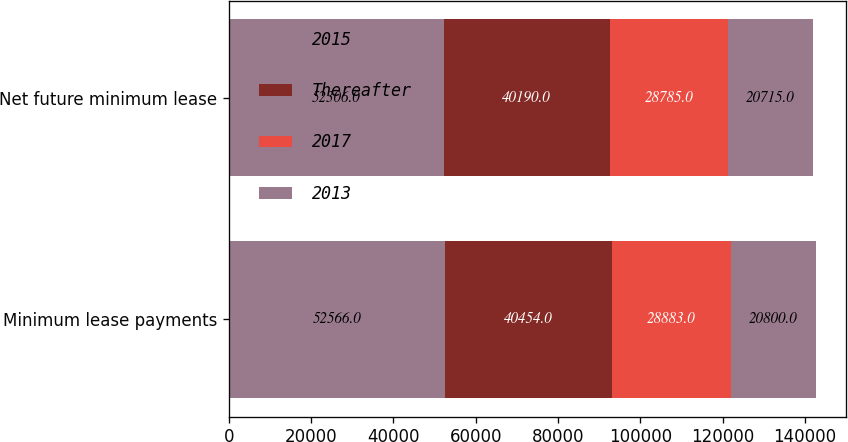Convert chart to OTSL. <chart><loc_0><loc_0><loc_500><loc_500><stacked_bar_chart><ecel><fcel>Minimum lease payments<fcel>Net future minimum lease<nl><fcel>2015<fcel>52566<fcel>52306<nl><fcel>Thereafter<fcel>40454<fcel>40190<nl><fcel>2017<fcel>28883<fcel>28785<nl><fcel>2013<fcel>20800<fcel>20715<nl></chart> 